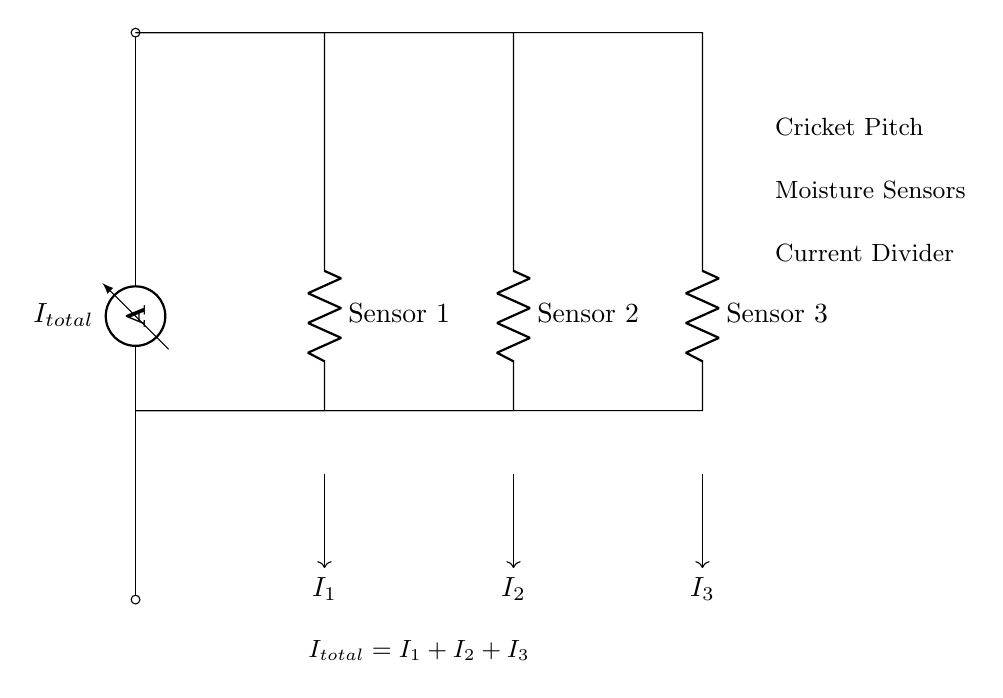What is the total current in the circuit? The total current, labeled as I total, is the sum of the currents through each sensor (I 1, I 2, I 3). Since the equation states that total current is equal to I 1 plus I 2 plus I 3, the total current is the aggregate of those individual currents.
Answer: I total What does R represent in the circuit? R represents the resistance of each sensor in the current divider configuration. In this circuit, there are three resistances labeled as R 1, R 2, and R 3, corresponding to Sensor 1, Sensor 2, and Sensor 3, respectively.
Answer: Resistance How many moisture sensors are shown in this diagram? The diagram displays three moisture sensors, indicated by the labels for R 1, R 2, and R 3. Each resistance corresponds to a different moisture sensor in the cricket pitch.
Answer: Three What is the relationship between I total and I 1, I 2, and I 3? The relationship is expressed in the equation I total equals I 1 plus I 2 plus I 3, indicating that the total current is distributed among the three sensors. This demonstrates how the current divider works, where the total current splits into separate paths for each sensor.
Answer: I total equals I 1 plus I 2 plus I 3 If R 1 has a higher resistance than R 2, which sensor receives more current? Since current flows more readily through lower resistance, Sensor 2 (with R 2) will receive more current compared to Sensor 1 (with R 1). This behavior is characteristic of current dividers whereby current inversely relates to resistance.
Answer: Sensor 2 What type of circuit is represented in this diagram? The circuit is a current divider, which is designed to split the input current into several output paths, typically through resistive components. The arrangement allows for the measurement of current in different paths which is useful for monitoring moisture levels in each section of the cricket pitch.
Answer: Current divider 